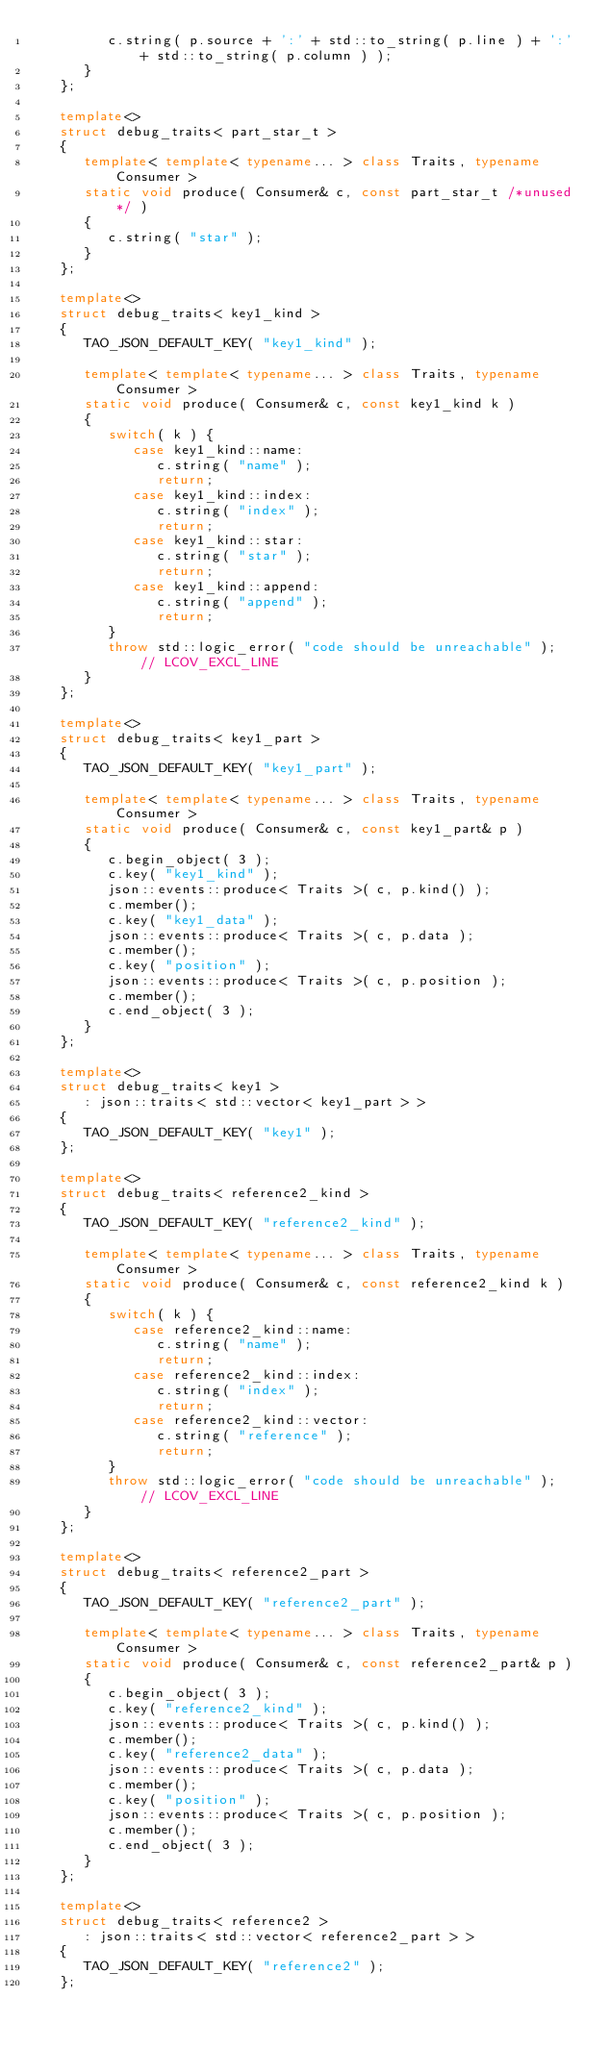Convert code to text. <code><loc_0><loc_0><loc_500><loc_500><_C++_>         c.string( p.source + ':' + std::to_string( p.line ) + ':' + std::to_string( p.column ) );
      }
   };

   template<>
   struct debug_traits< part_star_t >
   {
      template< template< typename... > class Traits, typename Consumer >
      static void produce( Consumer& c, const part_star_t /*unused*/ )
      {
         c.string( "star" );
      }
   };

   template<>
   struct debug_traits< key1_kind >
   {
      TAO_JSON_DEFAULT_KEY( "key1_kind" );

      template< template< typename... > class Traits, typename Consumer >
      static void produce( Consumer& c, const key1_kind k )
      {
         switch( k ) {
            case key1_kind::name:
               c.string( "name" );
               return;
            case key1_kind::index:
               c.string( "index" );
               return;
            case key1_kind::star:
               c.string( "star" );
               return;
            case key1_kind::append:
               c.string( "append" );
               return;
         }
         throw std::logic_error( "code should be unreachable" );  // LCOV_EXCL_LINE
      }
   };

   template<>
   struct debug_traits< key1_part >
   {
      TAO_JSON_DEFAULT_KEY( "key1_part" );

      template< template< typename... > class Traits, typename Consumer >
      static void produce( Consumer& c, const key1_part& p )
      {
         c.begin_object( 3 );
         c.key( "key1_kind" );
         json::events::produce< Traits >( c, p.kind() );
         c.member();
         c.key( "key1_data" );
         json::events::produce< Traits >( c, p.data );
         c.member();
         c.key( "position" );
         json::events::produce< Traits >( c, p.position );
         c.member();
         c.end_object( 3 );
      }
   };

   template<>
   struct debug_traits< key1 >
      : json::traits< std::vector< key1_part > >
   {
      TAO_JSON_DEFAULT_KEY( "key1" );
   };

   template<>
   struct debug_traits< reference2_kind >
   {
      TAO_JSON_DEFAULT_KEY( "reference2_kind" );

      template< template< typename... > class Traits, typename Consumer >
      static void produce( Consumer& c, const reference2_kind k )
      {
         switch( k ) {
            case reference2_kind::name:
               c.string( "name" );
               return;
            case reference2_kind::index:
               c.string( "index" );
               return;
            case reference2_kind::vector:
               c.string( "reference" );
               return;
         }
         throw std::logic_error( "code should be unreachable" );  // LCOV_EXCL_LINE
      }
   };

   template<>
   struct debug_traits< reference2_part >
   {
      TAO_JSON_DEFAULT_KEY( "reference2_part" );

      template< template< typename... > class Traits, typename Consumer >
      static void produce( Consumer& c, const reference2_part& p )
      {
         c.begin_object( 3 );
         c.key( "reference2_kind" );
         json::events::produce< Traits >( c, p.kind() );
         c.member();
         c.key( "reference2_data" );
         json::events::produce< Traits >( c, p.data );
         c.member();
         c.key( "position" );
         json::events::produce< Traits >( c, p.position );
         c.member();
         c.end_object( 3 );
      }
   };

   template<>
   struct debug_traits< reference2 >
      : json::traits< std::vector< reference2_part > >
   {
      TAO_JSON_DEFAULT_KEY( "reference2" );
   };
</code> 